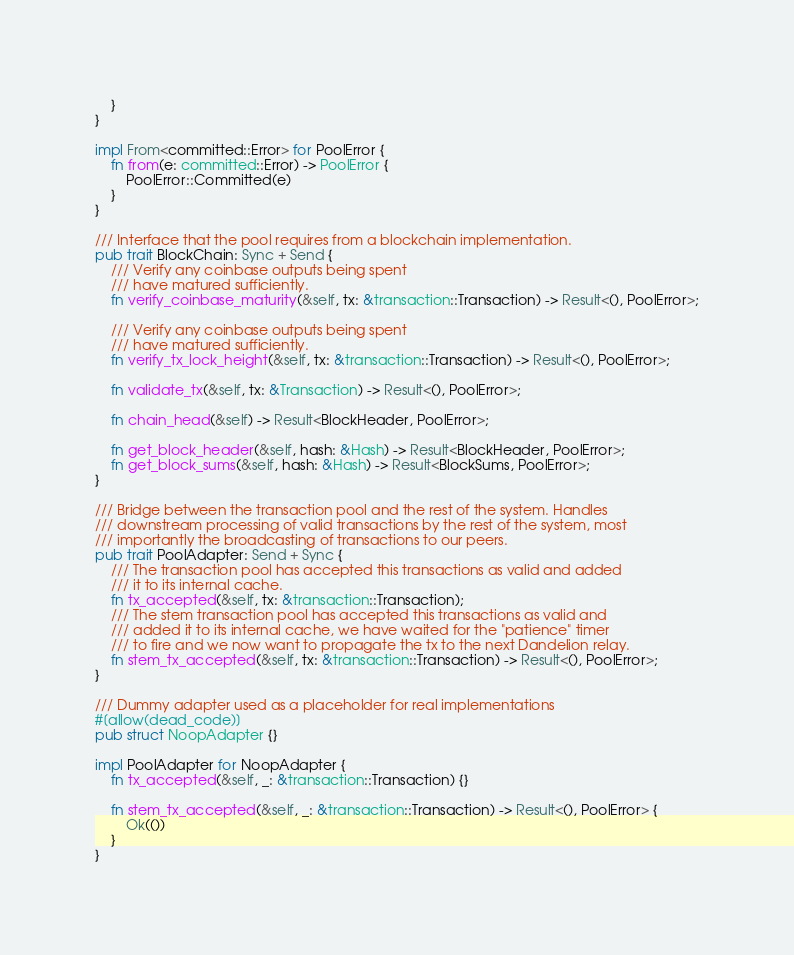Convert code to text. <code><loc_0><loc_0><loc_500><loc_500><_Rust_>	}
}

impl From<committed::Error> for PoolError {
	fn from(e: committed::Error) -> PoolError {
		PoolError::Committed(e)
	}
}

/// Interface that the pool requires from a blockchain implementation.
pub trait BlockChain: Sync + Send {
	/// Verify any coinbase outputs being spent
	/// have matured sufficiently.
	fn verify_coinbase_maturity(&self, tx: &transaction::Transaction) -> Result<(), PoolError>;

	/// Verify any coinbase outputs being spent
	/// have matured sufficiently.
	fn verify_tx_lock_height(&self, tx: &transaction::Transaction) -> Result<(), PoolError>;

	fn validate_tx(&self, tx: &Transaction) -> Result<(), PoolError>;

	fn chain_head(&self) -> Result<BlockHeader, PoolError>;

	fn get_block_header(&self, hash: &Hash) -> Result<BlockHeader, PoolError>;
	fn get_block_sums(&self, hash: &Hash) -> Result<BlockSums, PoolError>;
}

/// Bridge between the transaction pool and the rest of the system. Handles
/// downstream processing of valid transactions by the rest of the system, most
/// importantly the broadcasting of transactions to our peers.
pub trait PoolAdapter: Send + Sync {
	/// The transaction pool has accepted this transactions as valid and added
	/// it to its internal cache.
	fn tx_accepted(&self, tx: &transaction::Transaction);
	/// The stem transaction pool has accepted this transactions as valid and
	/// added it to its internal cache, we have waited for the "patience" timer
	/// to fire and we now want to propagate the tx to the next Dandelion relay.
	fn stem_tx_accepted(&self, tx: &transaction::Transaction) -> Result<(), PoolError>;
}

/// Dummy adapter used as a placeholder for real implementations
#[allow(dead_code)]
pub struct NoopAdapter {}

impl PoolAdapter for NoopAdapter {
	fn tx_accepted(&self, _: &transaction::Transaction) {}

	fn stem_tx_accepted(&self, _: &transaction::Transaction) -> Result<(), PoolError> {
		Ok(())
	}
}
</code> 